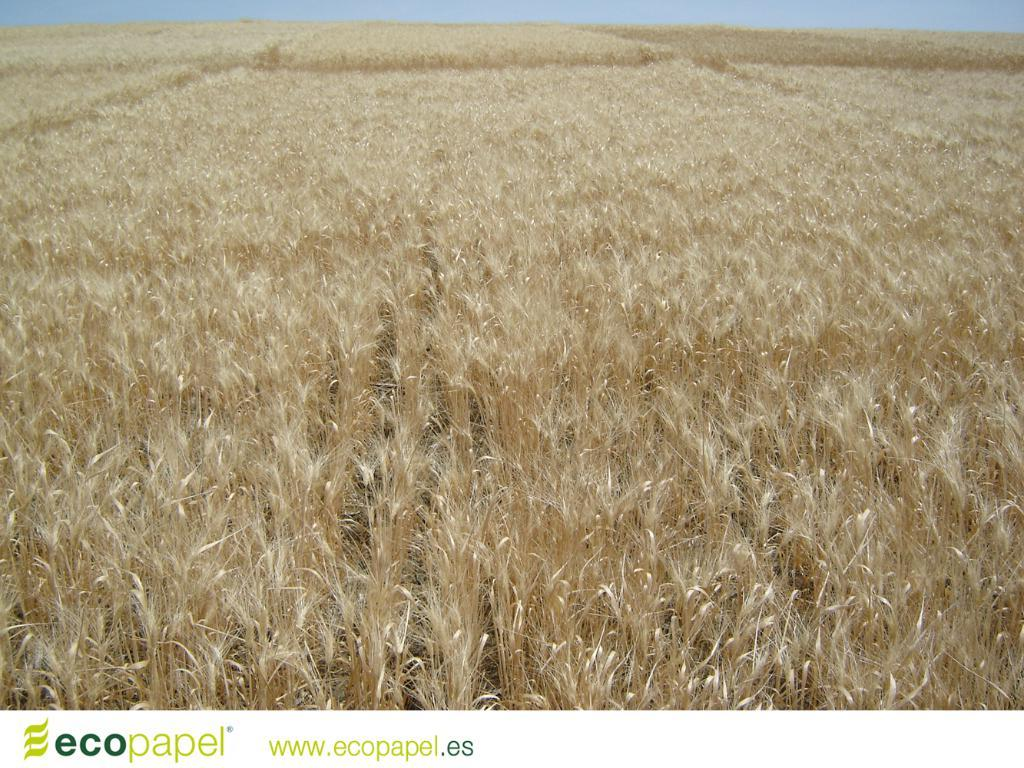What is the main subject of the image? The main subject of the image is a crop. Is there any text present in the image? Yes, there is text in the bottom left of the image. How many ducks are swimming in the crop in the image? There are no ducks present in the image; it features a crop and text. What type of paste is being used to create the text in the image? There is no information about the type of paste used for the text in the image, as it is not mentioned in the provided facts. 